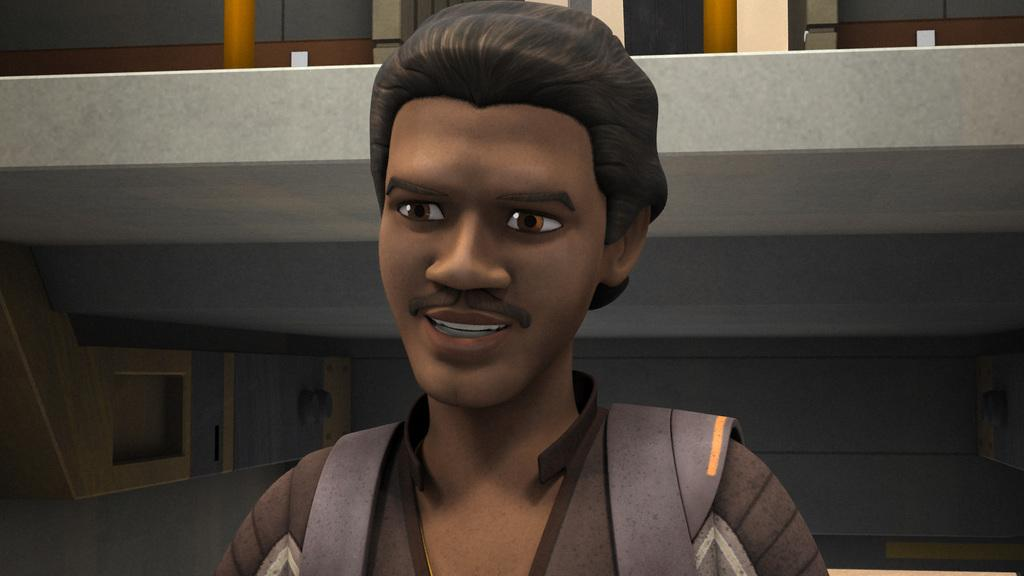What is the main subject of the image? There is a depiction of a person in the center of the image. Can you describe the setting of the image? There is a building in the background of the image. What type of thread is being used by the person in the image? There is no thread present in the image, as it only features a person and a building in the background. 